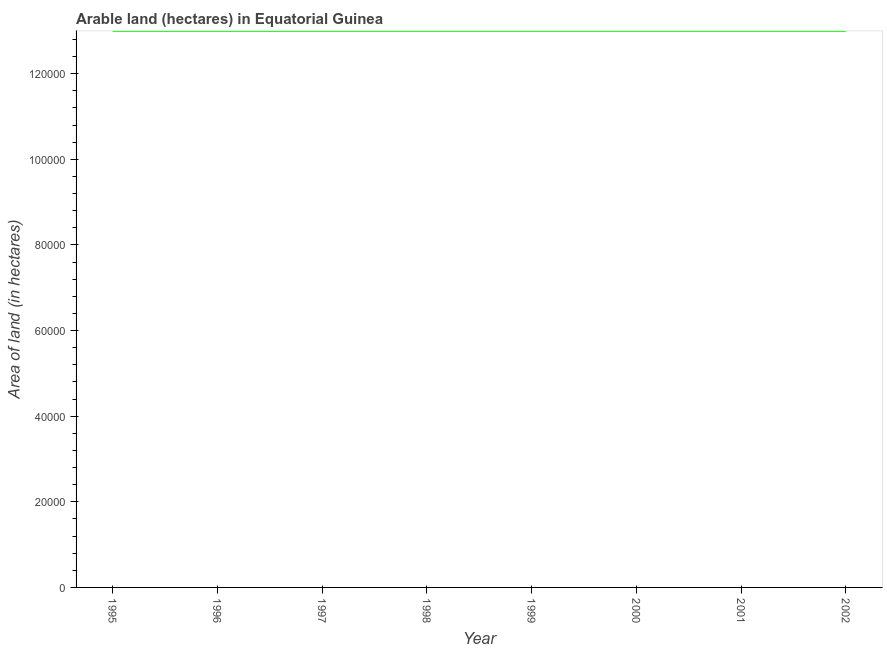What is the area of land in 2000?
Provide a succinct answer. 1.30e+05. Across all years, what is the maximum area of land?
Keep it short and to the point. 1.30e+05. Across all years, what is the minimum area of land?
Your answer should be compact. 1.30e+05. In which year was the area of land maximum?
Offer a terse response. 1995. What is the sum of the area of land?
Keep it short and to the point. 1.04e+06. What is the average area of land per year?
Your response must be concise. 1.30e+05. In how many years, is the area of land greater than 120000 hectares?
Give a very brief answer. 8. What is the ratio of the area of land in 1995 to that in 2001?
Your answer should be compact. 1. Is the area of land in 1995 less than that in 1997?
Give a very brief answer. No. Is the difference between the area of land in 2000 and 2002 greater than the difference between any two years?
Keep it short and to the point. Yes. Is the sum of the area of land in 1996 and 1998 greater than the maximum area of land across all years?
Keep it short and to the point. Yes. What is the difference between the highest and the lowest area of land?
Your response must be concise. 0. In how many years, is the area of land greater than the average area of land taken over all years?
Offer a very short reply. 0. How many years are there in the graph?
Offer a terse response. 8. What is the difference between two consecutive major ticks on the Y-axis?
Offer a terse response. 2.00e+04. Are the values on the major ticks of Y-axis written in scientific E-notation?
Your answer should be very brief. No. Does the graph contain grids?
Offer a terse response. No. What is the title of the graph?
Give a very brief answer. Arable land (hectares) in Equatorial Guinea. What is the label or title of the X-axis?
Offer a very short reply. Year. What is the label or title of the Y-axis?
Offer a very short reply. Area of land (in hectares). What is the Area of land (in hectares) of 1995?
Offer a terse response. 1.30e+05. What is the Area of land (in hectares) of 1998?
Give a very brief answer. 1.30e+05. What is the Area of land (in hectares) of 2002?
Make the answer very short. 1.30e+05. What is the difference between the Area of land (in hectares) in 1995 and 1996?
Offer a terse response. 0. What is the difference between the Area of land (in hectares) in 1995 and 1997?
Keep it short and to the point. 0. What is the difference between the Area of land (in hectares) in 1995 and 1998?
Give a very brief answer. 0. What is the difference between the Area of land (in hectares) in 1995 and 2002?
Provide a succinct answer. 0. What is the difference between the Area of land (in hectares) in 1996 and 1997?
Your answer should be very brief. 0. What is the difference between the Area of land (in hectares) in 1996 and 1999?
Your response must be concise. 0. What is the difference between the Area of land (in hectares) in 1996 and 2002?
Your answer should be compact. 0. What is the difference between the Area of land (in hectares) in 1997 and 2000?
Provide a short and direct response. 0. What is the difference between the Area of land (in hectares) in 1997 and 2001?
Offer a very short reply. 0. What is the difference between the Area of land (in hectares) in 1998 and 2000?
Your answer should be compact. 0. What is the difference between the Area of land (in hectares) in 1998 and 2001?
Offer a terse response. 0. What is the difference between the Area of land (in hectares) in 1998 and 2002?
Provide a short and direct response. 0. What is the difference between the Area of land (in hectares) in 2000 and 2002?
Your answer should be very brief. 0. What is the difference between the Area of land (in hectares) in 2001 and 2002?
Provide a short and direct response. 0. What is the ratio of the Area of land (in hectares) in 1995 to that in 1996?
Your response must be concise. 1. What is the ratio of the Area of land (in hectares) in 1995 to that in 1998?
Make the answer very short. 1. What is the ratio of the Area of land (in hectares) in 1995 to that in 2000?
Provide a succinct answer. 1. What is the ratio of the Area of land (in hectares) in 1995 to that in 2001?
Keep it short and to the point. 1. What is the ratio of the Area of land (in hectares) in 1995 to that in 2002?
Ensure brevity in your answer.  1. What is the ratio of the Area of land (in hectares) in 1996 to that in 1998?
Offer a terse response. 1. What is the ratio of the Area of land (in hectares) in 1996 to that in 2000?
Your answer should be compact. 1. What is the ratio of the Area of land (in hectares) in 1997 to that in 1999?
Your response must be concise. 1. What is the ratio of the Area of land (in hectares) in 1997 to that in 2000?
Your response must be concise. 1. What is the ratio of the Area of land (in hectares) in 1997 to that in 2001?
Provide a short and direct response. 1. What is the ratio of the Area of land (in hectares) in 1998 to that in 2000?
Keep it short and to the point. 1. What is the ratio of the Area of land (in hectares) in 1998 to that in 2001?
Offer a terse response. 1. What is the ratio of the Area of land (in hectares) in 1999 to that in 2002?
Keep it short and to the point. 1. What is the ratio of the Area of land (in hectares) in 2000 to that in 2001?
Ensure brevity in your answer.  1. What is the ratio of the Area of land (in hectares) in 2000 to that in 2002?
Ensure brevity in your answer.  1. What is the ratio of the Area of land (in hectares) in 2001 to that in 2002?
Make the answer very short. 1. 